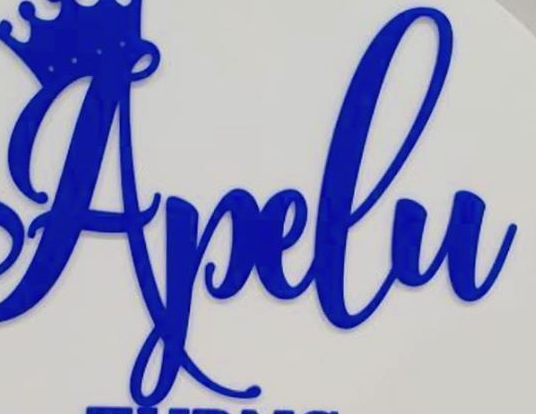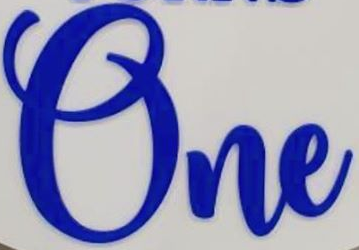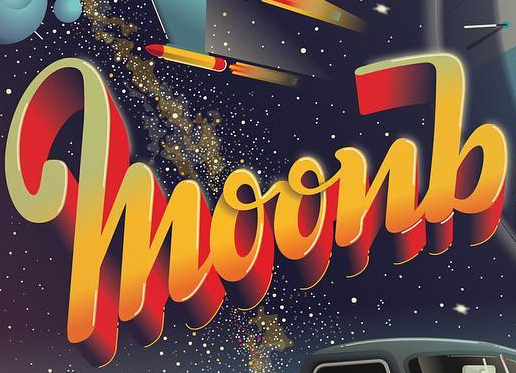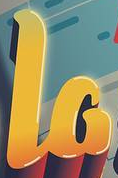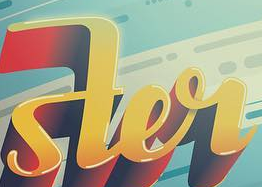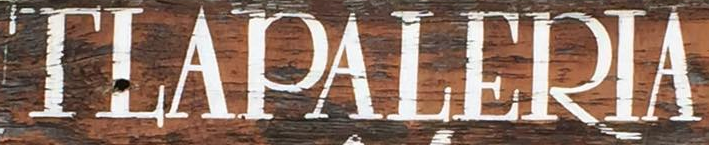What text is displayed in these images sequentially, separated by a semicolon? Apelu; One; moonb; la; ster; TLAPALERIA 